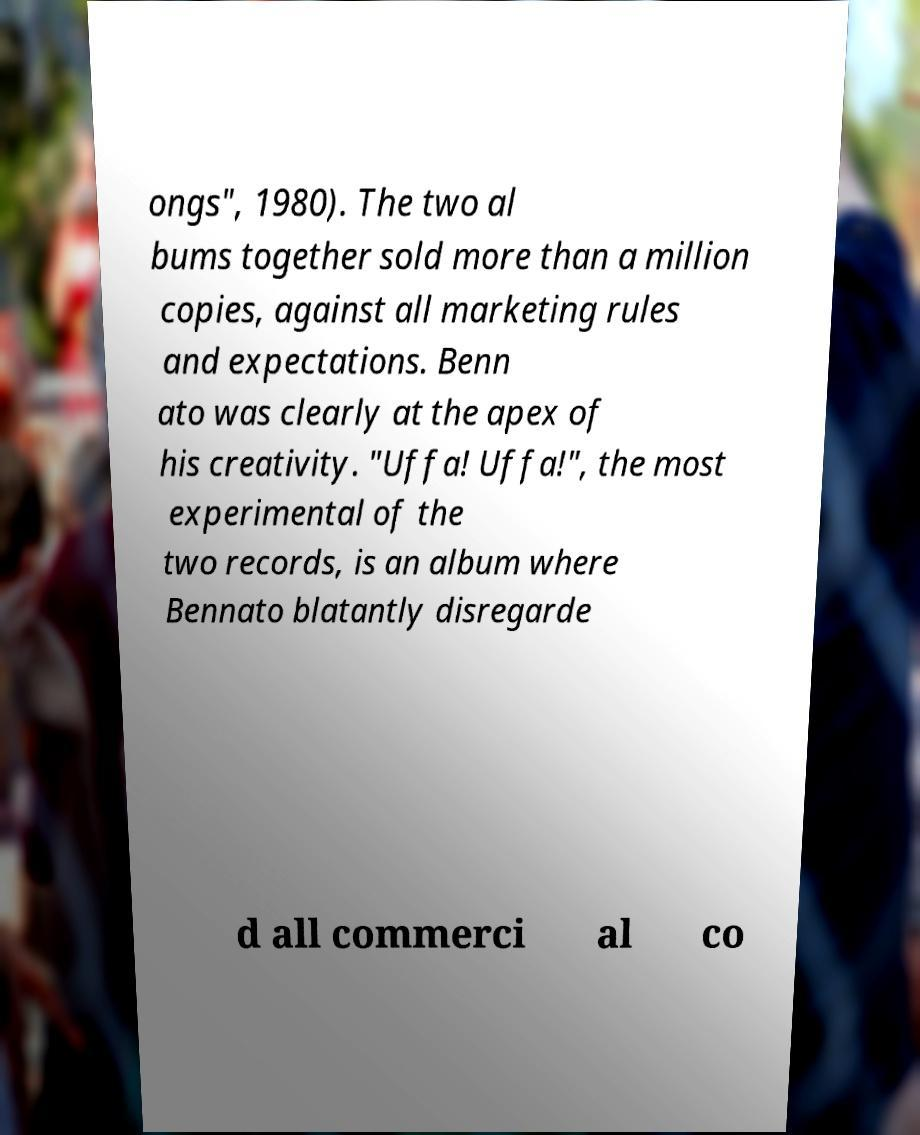Please identify and transcribe the text found in this image. ongs", 1980). The two al bums together sold more than a million copies, against all marketing rules and expectations. Benn ato was clearly at the apex of his creativity. "Uffa! Uffa!", the most experimental of the two records, is an album where Bennato blatantly disregarde d all commerci al co 